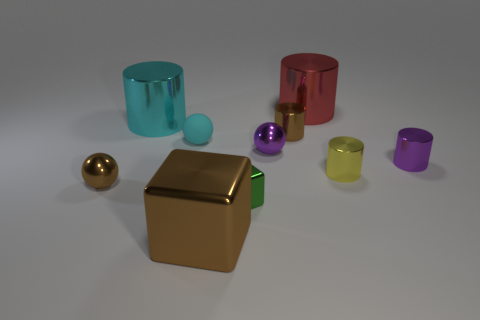What shape is the shiny thing that is the same color as the tiny matte sphere?
Your answer should be very brief. Cylinder. Is there a rubber ball that has the same color as the large metal cube?
Make the answer very short. No. What number of things are small cylinders that are behind the yellow metal cylinder or large brown things?
Offer a very short reply. 3. How many other things are the same size as the green metallic block?
Your answer should be very brief. 6. What is the material of the cube that is left of the metallic block behind the brown shiny thing in front of the brown metallic sphere?
Your answer should be compact. Metal. How many cubes are either large blue metal objects or tiny shiny things?
Offer a terse response. 1. Is there any other thing that is the same shape as the large red thing?
Your answer should be very brief. Yes. Is the number of brown balls right of the cyan matte thing greater than the number of small cyan objects on the left side of the green cube?
Make the answer very short. No. There is a big cyan cylinder that is in front of the red metal cylinder; what number of brown things are to the left of it?
Provide a short and direct response. 1. What number of things are either purple metal spheres or small yellow metallic cylinders?
Your answer should be compact. 2. 